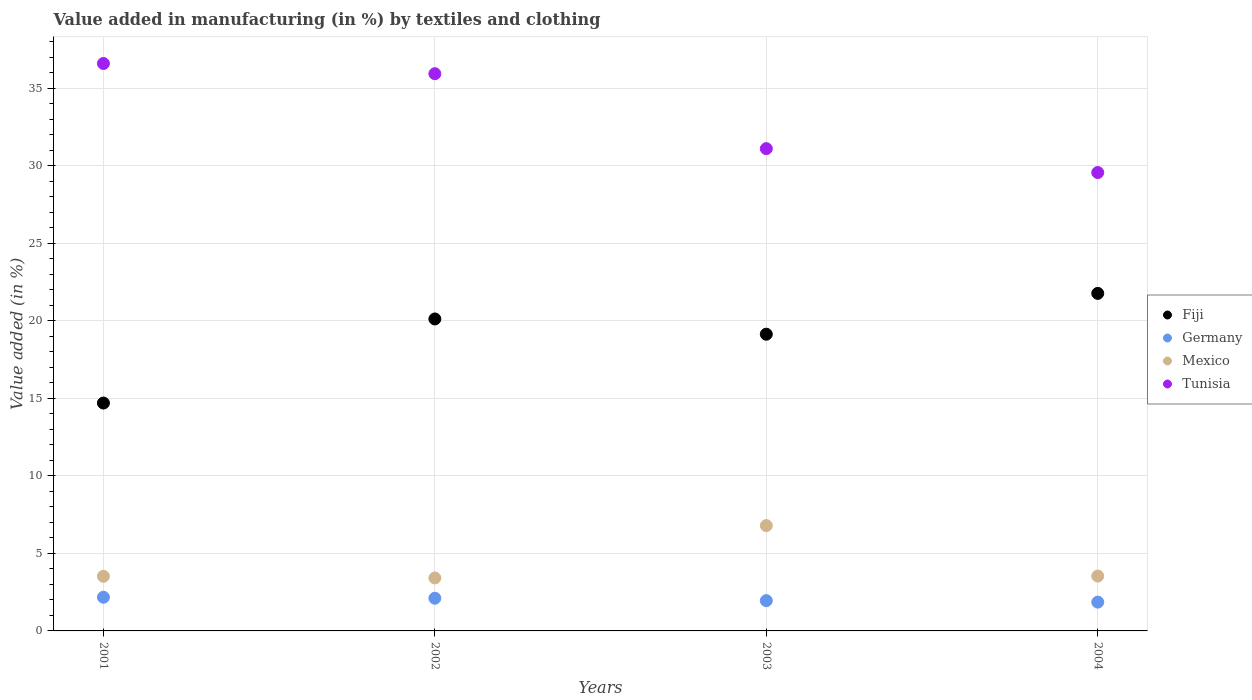How many different coloured dotlines are there?
Give a very brief answer. 4. Is the number of dotlines equal to the number of legend labels?
Offer a terse response. Yes. What is the percentage of value added in manufacturing by textiles and clothing in Germany in 2003?
Your answer should be compact. 1.95. Across all years, what is the maximum percentage of value added in manufacturing by textiles and clothing in Germany?
Keep it short and to the point. 2.17. Across all years, what is the minimum percentage of value added in manufacturing by textiles and clothing in Mexico?
Ensure brevity in your answer.  3.42. In which year was the percentage of value added in manufacturing by textiles and clothing in Tunisia minimum?
Provide a short and direct response. 2004. What is the total percentage of value added in manufacturing by textiles and clothing in Mexico in the graph?
Ensure brevity in your answer.  17.27. What is the difference between the percentage of value added in manufacturing by textiles and clothing in Fiji in 2002 and that in 2003?
Ensure brevity in your answer.  0.98. What is the difference between the percentage of value added in manufacturing by textiles and clothing in Mexico in 2002 and the percentage of value added in manufacturing by textiles and clothing in Germany in 2001?
Make the answer very short. 1.24. What is the average percentage of value added in manufacturing by textiles and clothing in Tunisia per year?
Your answer should be very brief. 33.31. In the year 2002, what is the difference between the percentage of value added in manufacturing by textiles and clothing in Fiji and percentage of value added in manufacturing by textiles and clothing in Mexico?
Ensure brevity in your answer.  16.71. What is the ratio of the percentage of value added in manufacturing by textiles and clothing in Germany in 2001 to that in 2003?
Offer a very short reply. 1.11. Is the difference between the percentage of value added in manufacturing by textiles and clothing in Fiji in 2002 and 2003 greater than the difference between the percentage of value added in manufacturing by textiles and clothing in Mexico in 2002 and 2003?
Make the answer very short. Yes. What is the difference between the highest and the second highest percentage of value added in manufacturing by textiles and clothing in Mexico?
Provide a succinct answer. 3.26. What is the difference between the highest and the lowest percentage of value added in manufacturing by textiles and clothing in Fiji?
Offer a terse response. 7.07. In how many years, is the percentage of value added in manufacturing by textiles and clothing in Tunisia greater than the average percentage of value added in manufacturing by textiles and clothing in Tunisia taken over all years?
Your answer should be compact. 2. Is the sum of the percentage of value added in manufacturing by textiles and clothing in Mexico in 2001 and 2002 greater than the maximum percentage of value added in manufacturing by textiles and clothing in Germany across all years?
Give a very brief answer. Yes. Is it the case that in every year, the sum of the percentage of value added in manufacturing by textiles and clothing in Mexico and percentage of value added in manufacturing by textiles and clothing in Germany  is greater than the sum of percentage of value added in manufacturing by textiles and clothing in Tunisia and percentage of value added in manufacturing by textiles and clothing in Fiji?
Keep it short and to the point. No. How many years are there in the graph?
Ensure brevity in your answer.  4. What is the difference between two consecutive major ticks on the Y-axis?
Give a very brief answer. 5. Does the graph contain any zero values?
Offer a very short reply. No. Does the graph contain grids?
Offer a very short reply. Yes. Where does the legend appear in the graph?
Make the answer very short. Center right. How many legend labels are there?
Make the answer very short. 4. What is the title of the graph?
Keep it short and to the point. Value added in manufacturing (in %) by textiles and clothing. Does "Bosnia and Herzegovina" appear as one of the legend labels in the graph?
Provide a succinct answer. No. What is the label or title of the X-axis?
Offer a terse response. Years. What is the label or title of the Y-axis?
Offer a very short reply. Value added (in %). What is the Value added (in %) in Fiji in 2001?
Offer a terse response. 14.7. What is the Value added (in %) of Germany in 2001?
Provide a short and direct response. 2.17. What is the Value added (in %) of Mexico in 2001?
Ensure brevity in your answer.  3.52. What is the Value added (in %) in Tunisia in 2001?
Provide a succinct answer. 36.61. What is the Value added (in %) in Fiji in 2002?
Make the answer very short. 20.13. What is the Value added (in %) in Germany in 2002?
Provide a short and direct response. 2.11. What is the Value added (in %) in Mexico in 2002?
Provide a succinct answer. 3.42. What is the Value added (in %) of Tunisia in 2002?
Offer a very short reply. 35.95. What is the Value added (in %) of Fiji in 2003?
Your answer should be very brief. 19.14. What is the Value added (in %) in Germany in 2003?
Your response must be concise. 1.95. What is the Value added (in %) in Mexico in 2003?
Keep it short and to the point. 6.79. What is the Value added (in %) in Tunisia in 2003?
Make the answer very short. 31.11. What is the Value added (in %) of Fiji in 2004?
Provide a succinct answer. 21.77. What is the Value added (in %) in Germany in 2004?
Keep it short and to the point. 1.86. What is the Value added (in %) in Mexico in 2004?
Your answer should be compact. 3.54. What is the Value added (in %) in Tunisia in 2004?
Offer a very short reply. 29.57. Across all years, what is the maximum Value added (in %) of Fiji?
Offer a terse response. 21.77. Across all years, what is the maximum Value added (in %) in Germany?
Your response must be concise. 2.17. Across all years, what is the maximum Value added (in %) in Mexico?
Keep it short and to the point. 6.79. Across all years, what is the maximum Value added (in %) in Tunisia?
Your response must be concise. 36.61. Across all years, what is the minimum Value added (in %) of Fiji?
Offer a very short reply. 14.7. Across all years, what is the minimum Value added (in %) in Germany?
Your answer should be very brief. 1.86. Across all years, what is the minimum Value added (in %) in Mexico?
Your answer should be compact. 3.42. Across all years, what is the minimum Value added (in %) in Tunisia?
Offer a terse response. 29.57. What is the total Value added (in %) of Fiji in the graph?
Give a very brief answer. 75.74. What is the total Value added (in %) of Germany in the graph?
Offer a very short reply. 8.09. What is the total Value added (in %) of Mexico in the graph?
Provide a succinct answer. 17.27. What is the total Value added (in %) in Tunisia in the graph?
Your answer should be compact. 133.24. What is the difference between the Value added (in %) in Fiji in 2001 and that in 2002?
Provide a succinct answer. -5.42. What is the difference between the Value added (in %) in Germany in 2001 and that in 2002?
Give a very brief answer. 0.07. What is the difference between the Value added (in %) in Mexico in 2001 and that in 2002?
Make the answer very short. 0.11. What is the difference between the Value added (in %) in Tunisia in 2001 and that in 2002?
Provide a succinct answer. 0.66. What is the difference between the Value added (in %) of Fiji in 2001 and that in 2003?
Your answer should be very brief. -4.44. What is the difference between the Value added (in %) of Germany in 2001 and that in 2003?
Your answer should be compact. 0.22. What is the difference between the Value added (in %) of Mexico in 2001 and that in 2003?
Offer a very short reply. -3.27. What is the difference between the Value added (in %) in Tunisia in 2001 and that in 2003?
Give a very brief answer. 5.49. What is the difference between the Value added (in %) in Fiji in 2001 and that in 2004?
Give a very brief answer. -7.07. What is the difference between the Value added (in %) of Germany in 2001 and that in 2004?
Provide a succinct answer. 0.32. What is the difference between the Value added (in %) of Mexico in 2001 and that in 2004?
Keep it short and to the point. -0.02. What is the difference between the Value added (in %) in Tunisia in 2001 and that in 2004?
Offer a very short reply. 7.03. What is the difference between the Value added (in %) of Fiji in 2002 and that in 2003?
Your answer should be very brief. 0.98. What is the difference between the Value added (in %) of Germany in 2002 and that in 2003?
Provide a succinct answer. 0.15. What is the difference between the Value added (in %) in Mexico in 2002 and that in 2003?
Provide a succinct answer. -3.38. What is the difference between the Value added (in %) in Tunisia in 2002 and that in 2003?
Offer a very short reply. 4.83. What is the difference between the Value added (in %) in Fiji in 2002 and that in 2004?
Your response must be concise. -1.65. What is the difference between the Value added (in %) of Germany in 2002 and that in 2004?
Provide a short and direct response. 0.25. What is the difference between the Value added (in %) of Mexico in 2002 and that in 2004?
Give a very brief answer. -0.12. What is the difference between the Value added (in %) in Tunisia in 2002 and that in 2004?
Your answer should be very brief. 6.38. What is the difference between the Value added (in %) in Fiji in 2003 and that in 2004?
Provide a succinct answer. -2.63. What is the difference between the Value added (in %) in Germany in 2003 and that in 2004?
Your answer should be very brief. 0.1. What is the difference between the Value added (in %) of Mexico in 2003 and that in 2004?
Your answer should be compact. 3.26. What is the difference between the Value added (in %) in Tunisia in 2003 and that in 2004?
Make the answer very short. 1.54. What is the difference between the Value added (in %) in Fiji in 2001 and the Value added (in %) in Germany in 2002?
Offer a very short reply. 12.59. What is the difference between the Value added (in %) of Fiji in 2001 and the Value added (in %) of Mexico in 2002?
Ensure brevity in your answer.  11.28. What is the difference between the Value added (in %) in Fiji in 2001 and the Value added (in %) in Tunisia in 2002?
Provide a succinct answer. -21.25. What is the difference between the Value added (in %) of Germany in 2001 and the Value added (in %) of Mexico in 2002?
Keep it short and to the point. -1.24. What is the difference between the Value added (in %) of Germany in 2001 and the Value added (in %) of Tunisia in 2002?
Provide a short and direct response. -33.77. What is the difference between the Value added (in %) of Mexico in 2001 and the Value added (in %) of Tunisia in 2002?
Keep it short and to the point. -32.43. What is the difference between the Value added (in %) of Fiji in 2001 and the Value added (in %) of Germany in 2003?
Provide a succinct answer. 12.75. What is the difference between the Value added (in %) in Fiji in 2001 and the Value added (in %) in Mexico in 2003?
Offer a very short reply. 7.91. What is the difference between the Value added (in %) of Fiji in 2001 and the Value added (in %) of Tunisia in 2003?
Your answer should be very brief. -16.41. What is the difference between the Value added (in %) in Germany in 2001 and the Value added (in %) in Mexico in 2003?
Offer a very short reply. -4.62. What is the difference between the Value added (in %) in Germany in 2001 and the Value added (in %) in Tunisia in 2003?
Offer a terse response. -28.94. What is the difference between the Value added (in %) of Mexico in 2001 and the Value added (in %) of Tunisia in 2003?
Provide a succinct answer. -27.59. What is the difference between the Value added (in %) in Fiji in 2001 and the Value added (in %) in Germany in 2004?
Provide a short and direct response. 12.84. What is the difference between the Value added (in %) in Fiji in 2001 and the Value added (in %) in Mexico in 2004?
Provide a succinct answer. 11.16. What is the difference between the Value added (in %) of Fiji in 2001 and the Value added (in %) of Tunisia in 2004?
Offer a very short reply. -14.87. What is the difference between the Value added (in %) in Germany in 2001 and the Value added (in %) in Mexico in 2004?
Provide a short and direct response. -1.37. What is the difference between the Value added (in %) of Germany in 2001 and the Value added (in %) of Tunisia in 2004?
Your answer should be compact. -27.4. What is the difference between the Value added (in %) of Mexico in 2001 and the Value added (in %) of Tunisia in 2004?
Provide a short and direct response. -26.05. What is the difference between the Value added (in %) in Fiji in 2002 and the Value added (in %) in Germany in 2003?
Ensure brevity in your answer.  18.17. What is the difference between the Value added (in %) of Fiji in 2002 and the Value added (in %) of Mexico in 2003?
Keep it short and to the point. 13.33. What is the difference between the Value added (in %) of Fiji in 2002 and the Value added (in %) of Tunisia in 2003?
Give a very brief answer. -10.99. What is the difference between the Value added (in %) of Germany in 2002 and the Value added (in %) of Mexico in 2003?
Make the answer very short. -4.69. What is the difference between the Value added (in %) in Germany in 2002 and the Value added (in %) in Tunisia in 2003?
Your answer should be compact. -29. What is the difference between the Value added (in %) in Mexico in 2002 and the Value added (in %) in Tunisia in 2003?
Offer a very short reply. -27.7. What is the difference between the Value added (in %) of Fiji in 2002 and the Value added (in %) of Germany in 2004?
Make the answer very short. 18.27. What is the difference between the Value added (in %) of Fiji in 2002 and the Value added (in %) of Mexico in 2004?
Your answer should be very brief. 16.59. What is the difference between the Value added (in %) in Fiji in 2002 and the Value added (in %) in Tunisia in 2004?
Offer a very short reply. -9.45. What is the difference between the Value added (in %) of Germany in 2002 and the Value added (in %) of Mexico in 2004?
Your answer should be compact. -1.43. What is the difference between the Value added (in %) of Germany in 2002 and the Value added (in %) of Tunisia in 2004?
Your answer should be compact. -27.46. What is the difference between the Value added (in %) in Mexico in 2002 and the Value added (in %) in Tunisia in 2004?
Your answer should be compact. -26.16. What is the difference between the Value added (in %) of Fiji in 2003 and the Value added (in %) of Germany in 2004?
Provide a succinct answer. 17.28. What is the difference between the Value added (in %) of Fiji in 2003 and the Value added (in %) of Mexico in 2004?
Make the answer very short. 15.6. What is the difference between the Value added (in %) in Fiji in 2003 and the Value added (in %) in Tunisia in 2004?
Your answer should be very brief. -10.43. What is the difference between the Value added (in %) of Germany in 2003 and the Value added (in %) of Mexico in 2004?
Your answer should be very brief. -1.58. What is the difference between the Value added (in %) in Germany in 2003 and the Value added (in %) in Tunisia in 2004?
Provide a succinct answer. -27.62. What is the difference between the Value added (in %) in Mexico in 2003 and the Value added (in %) in Tunisia in 2004?
Give a very brief answer. -22.78. What is the average Value added (in %) of Fiji per year?
Ensure brevity in your answer.  18.94. What is the average Value added (in %) of Germany per year?
Ensure brevity in your answer.  2.02. What is the average Value added (in %) in Mexico per year?
Offer a terse response. 4.32. What is the average Value added (in %) in Tunisia per year?
Offer a very short reply. 33.31. In the year 2001, what is the difference between the Value added (in %) of Fiji and Value added (in %) of Germany?
Provide a succinct answer. 12.53. In the year 2001, what is the difference between the Value added (in %) in Fiji and Value added (in %) in Mexico?
Your answer should be very brief. 11.18. In the year 2001, what is the difference between the Value added (in %) in Fiji and Value added (in %) in Tunisia?
Give a very brief answer. -21.9. In the year 2001, what is the difference between the Value added (in %) in Germany and Value added (in %) in Mexico?
Provide a succinct answer. -1.35. In the year 2001, what is the difference between the Value added (in %) of Germany and Value added (in %) of Tunisia?
Ensure brevity in your answer.  -34.43. In the year 2001, what is the difference between the Value added (in %) in Mexico and Value added (in %) in Tunisia?
Provide a succinct answer. -33.08. In the year 2002, what is the difference between the Value added (in %) of Fiji and Value added (in %) of Germany?
Offer a very short reply. 18.02. In the year 2002, what is the difference between the Value added (in %) in Fiji and Value added (in %) in Mexico?
Give a very brief answer. 16.71. In the year 2002, what is the difference between the Value added (in %) of Fiji and Value added (in %) of Tunisia?
Your response must be concise. -15.82. In the year 2002, what is the difference between the Value added (in %) in Germany and Value added (in %) in Mexico?
Provide a short and direct response. -1.31. In the year 2002, what is the difference between the Value added (in %) in Germany and Value added (in %) in Tunisia?
Provide a short and direct response. -33.84. In the year 2002, what is the difference between the Value added (in %) of Mexico and Value added (in %) of Tunisia?
Your answer should be very brief. -32.53. In the year 2003, what is the difference between the Value added (in %) in Fiji and Value added (in %) in Germany?
Offer a very short reply. 17.19. In the year 2003, what is the difference between the Value added (in %) in Fiji and Value added (in %) in Mexico?
Give a very brief answer. 12.35. In the year 2003, what is the difference between the Value added (in %) in Fiji and Value added (in %) in Tunisia?
Your answer should be compact. -11.97. In the year 2003, what is the difference between the Value added (in %) in Germany and Value added (in %) in Mexico?
Offer a very short reply. -4.84. In the year 2003, what is the difference between the Value added (in %) in Germany and Value added (in %) in Tunisia?
Make the answer very short. -29.16. In the year 2003, what is the difference between the Value added (in %) in Mexico and Value added (in %) in Tunisia?
Your response must be concise. -24.32. In the year 2004, what is the difference between the Value added (in %) of Fiji and Value added (in %) of Germany?
Ensure brevity in your answer.  19.92. In the year 2004, what is the difference between the Value added (in %) in Fiji and Value added (in %) in Mexico?
Provide a short and direct response. 18.24. In the year 2004, what is the difference between the Value added (in %) in Fiji and Value added (in %) in Tunisia?
Offer a very short reply. -7.8. In the year 2004, what is the difference between the Value added (in %) of Germany and Value added (in %) of Mexico?
Provide a short and direct response. -1.68. In the year 2004, what is the difference between the Value added (in %) in Germany and Value added (in %) in Tunisia?
Provide a succinct answer. -27.71. In the year 2004, what is the difference between the Value added (in %) of Mexico and Value added (in %) of Tunisia?
Provide a succinct answer. -26.03. What is the ratio of the Value added (in %) of Fiji in 2001 to that in 2002?
Make the answer very short. 0.73. What is the ratio of the Value added (in %) in Germany in 2001 to that in 2002?
Your answer should be compact. 1.03. What is the ratio of the Value added (in %) of Mexico in 2001 to that in 2002?
Provide a succinct answer. 1.03. What is the ratio of the Value added (in %) in Tunisia in 2001 to that in 2002?
Keep it short and to the point. 1.02. What is the ratio of the Value added (in %) in Fiji in 2001 to that in 2003?
Your response must be concise. 0.77. What is the ratio of the Value added (in %) in Germany in 2001 to that in 2003?
Give a very brief answer. 1.11. What is the ratio of the Value added (in %) in Mexico in 2001 to that in 2003?
Provide a succinct answer. 0.52. What is the ratio of the Value added (in %) of Tunisia in 2001 to that in 2003?
Provide a short and direct response. 1.18. What is the ratio of the Value added (in %) of Fiji in 2001 to that in 2004?
Provide a short and direct response. 0.68. What is the ratio of the Value added (in %) of Germany in 2001 to that in 2004?
Make the answer very short. 1.17. What is the ratio of the Value added (in %) of Mexico in 2001 to that in 2004?
Give a very brief answer. 1. What is the ratio of the Value added (in %) in Tunisia in 2001 to that in 2004?
Your answer should be compact. 1.24. What is the ratio of the Value added (in %) of Fiji in 2002 to that in 2003?
Provide a succinct answer. 1.05. What is the ratio of the Value added (in %) of Germany in 2002 to that in 2003?
Ensure brevity in your answer.  1.08. What is the ratio of the Value added (in %) of Mexico in 2002 to that in 2003?
Provide a short and direct response. 0.5. What is the ratio of the Value added (in %) in Tunisia in 2002 to that in 2003?
Your response must be concise. 1.16. What is the ratio of the Value added (in %) in Fiji in 2002 to that in 2004?
Provide a short and direct response. 0.92. What is the ratio of the Value added (in %) of Germany in 2002 to that in 2004?
Give a very brief answer. 1.14. What is the ratio of the Value added (in %) of Mexico in 2002 to that in 2004?
Provide a short and direct response. 0.97. What is the ratio of the Value added (in %) of Tunisia in 2002 to that in 2004?
Your answer should be very brief. 1.22. What is the ratio of the Value added (in %) of Fiji in 2003 to that in 2004?
Provide a succinct answer. 0.88. What is the ratio of the Value added (in %) in Germany in 2003 to that in 2004?
Your answer should be very brief. 1.05. What is the ratio of the Value added (in %) in Mexico in 2003 to that in 2004?
Provide a succinct answer. 1.92. What is the ratio of the Value added (in %) in Tunisia in 2003 to that in 2004?
Ensure brevity in your answer.  1.05. What is the difference between the highest and the second highest Value added (in %) of Fiji?
Provide a short and direct response. 1.65. What is the difference between the highest and the second highest Value added (in %) of Germany?
Make the answer very short. 0.07. What is the difference between the highest and the second highest Value added (in %) of Mexico?
Provide a succinct answer. 3.26. What is the difference between the highest and the second highest Value added (in %) of Tunisia?
Your answer should be compact. 0.66. What is the difference between the highest and the lowest Value added (in %) of Fiji?
Provide a succinct answer. 7.07. What is the difference between the highest and the lowest Value added (in %) in Germany?
Your answer should be compact. 0.32. What is the difference between the highest and the lowest Value added (in %) in Mexico?
Your answer should be compact. 3.38. What is the difference between the highest and the lowest Value added (in %) in Tunisia?
Give a very brief answer. 7.03. 